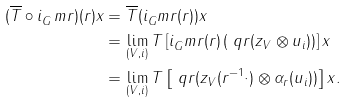Convert formula to latex. <formula><loc_0><loc_0><loc_500><loc_500>( \overline { T } \circ i _ { G } ^ { \ } m r ) ( r ) x & = \overline { T } ( i _ { G } ^ { \ } m r ( r ) ) x \\ & = \lim _ { ( V , i ) } T \left [ i _ { G } ^ { \ } m r ( r ) \left ( \ q r ( z _ { V } \otimes u _ { i } ) \right ) \right ] x \\ & = \lim _ { ( V , i ) } T \left [ \ q r ( z _ { V } ( r ^ { - 1 } \cdot ) \otimes \alpha _ { r } ( u _ { i } ) ) \right ] x .</formula> 